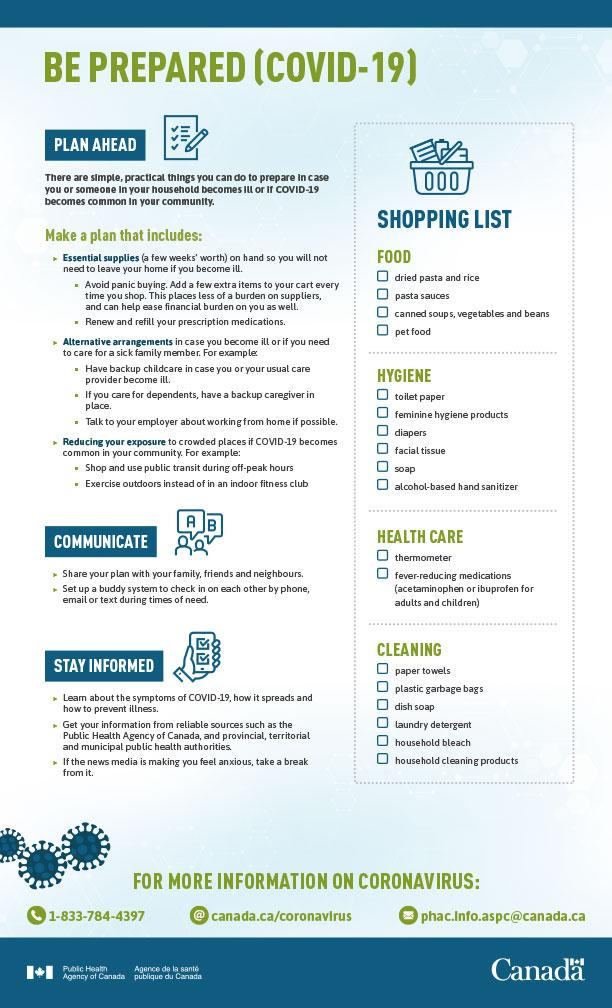Draw attention to some important aspects in this diagram. Dish soap is included in the cleaning section of the shopping list. The shopping list contains only two items in the health care section. There are four items listed under the category of "Food" in the shopping list. The sixth item on the hygiene shopping list is alcohol-based hand sanitizer. The medications for pain and fever mentioned in the list include acetaminophen and ibuprofen. 